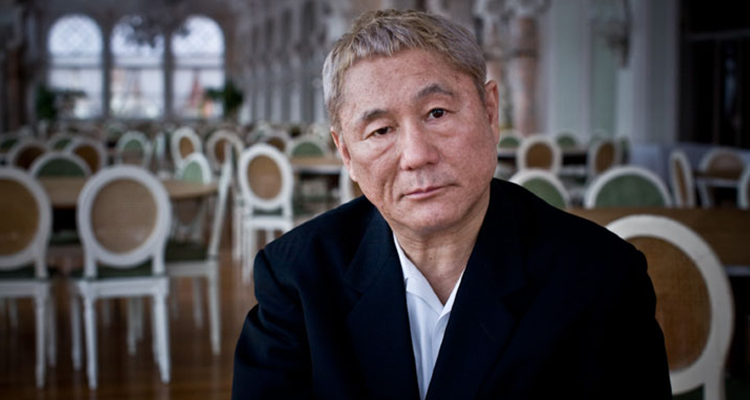Explain the visual content of the image in great detail. In the image, a distinguished gentleman is seated solemnly in a chandeliered dining hall. He is dressed in a classic black suit that sharply contrasts with the soft white tones of the empty chairs and neatly laid tables surrounding him. His expression, pensive and introspective, along with his slightly tousled hair, suggests a moment of serious consideration or a break in solitude. The grayscale color palette imbues the scene with a timeless quality, prompting reflection on the setting as perhaps before or after a significant event. 